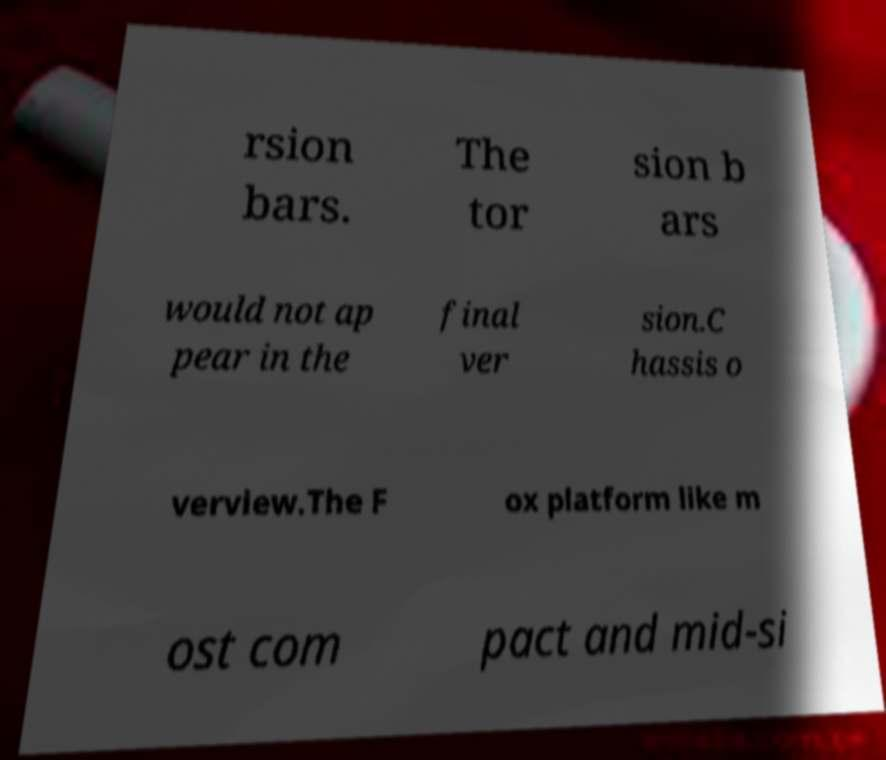I need the written content from this picture converted into text. Can you do that? rsion bars. The tor sion b ars would not ap pear in the final ver sion.C hassis o verview.The F ox platform like m ost com pact and mid-si 